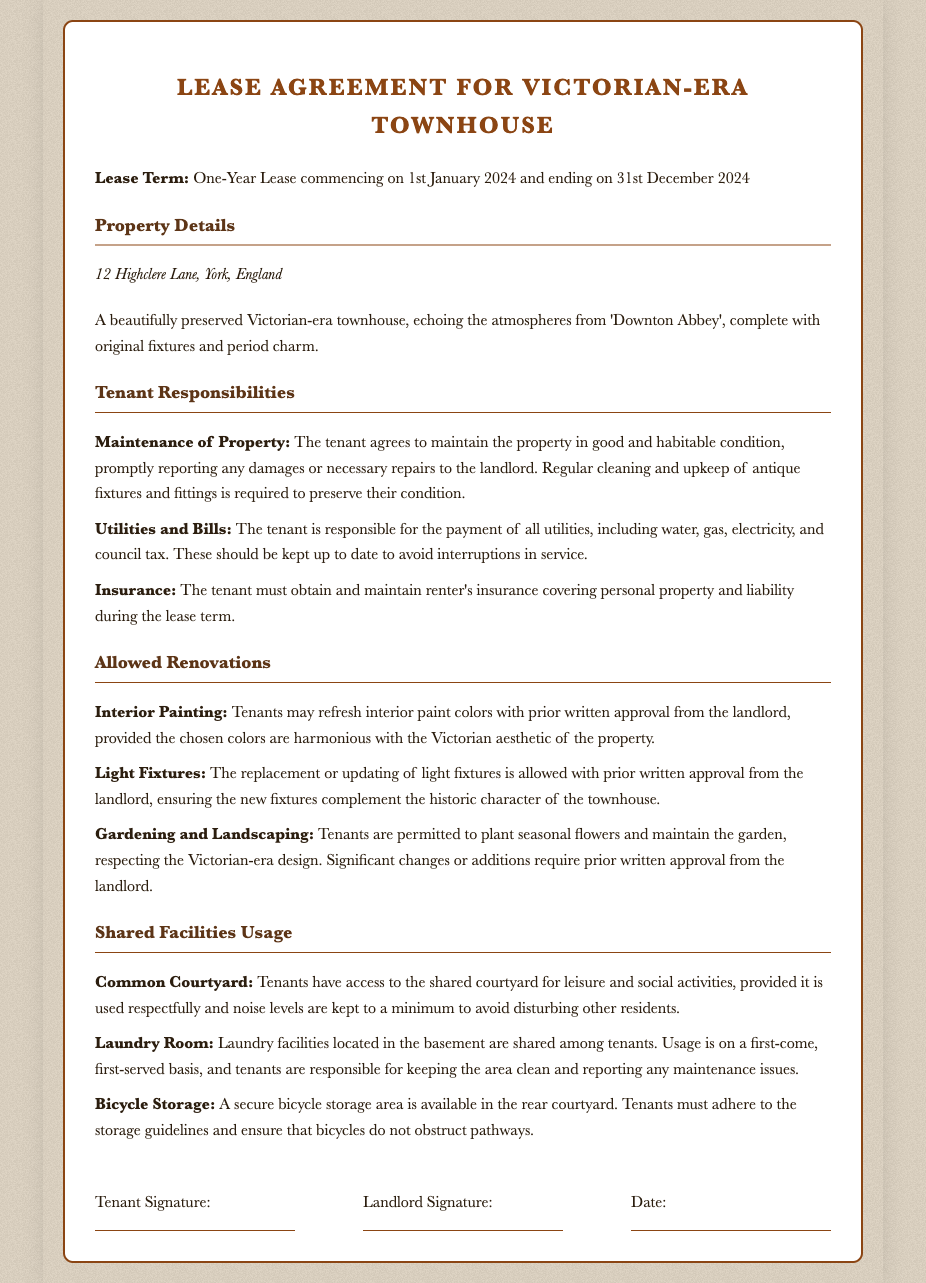What is the lease term? The lease term is specified at the beginning of the document, which covers a period from January 1, 2024, to December 31, 2024.
Answer: One-Year Lease What is the address of the property? The address is listed in the property details section of the document.
Answer: 12 Highclere Lane, York, England What is a tenant responsible for regarding property maintenance? The tenant's responsibility for maintenance includes keeping the property in good condition and reporting damages.
Answer: Maintain the property Are interior paint changes allowed? The document mentions that interior painting requires prior written approval, indicating it is allowed with conditions.
Answer: Yes What type of insurance must the tenant obtain? The insurance required from the tenant is specified in the tenant responsibilities section.
Answer: Renter's insurance Can tenants plant seasonal flowers in the garden? The allowed renovations section indicates tenants can plant seasonal flowers, but it must respect the Victorian-era design.
Answer: Yes How must tenants maintain the shared laundry room? The responsibilities regarding the shared laundry room are described in the shared facilities usage section, specifying the cleanliness obligation.
Answer: Keep the area clean What are tenants prohibited from doing with bicycles? The document indicates that bicycles must not obstruct pathways in the bicycle storage area.
Answer: Obstruct pathways What is the start date of the lease? The start date is clearly stated in the lease term section of the document.
Answer: January 1, 2024 